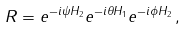<formula> <loc_0><loc_0><loc_500><loc_500>R = e ^ { - i \psi H _ { 2 } } e ^ { - i \theta H _ { 1 } } e ^ { - i \phi H _ { 2 } } \, ,</formula> 